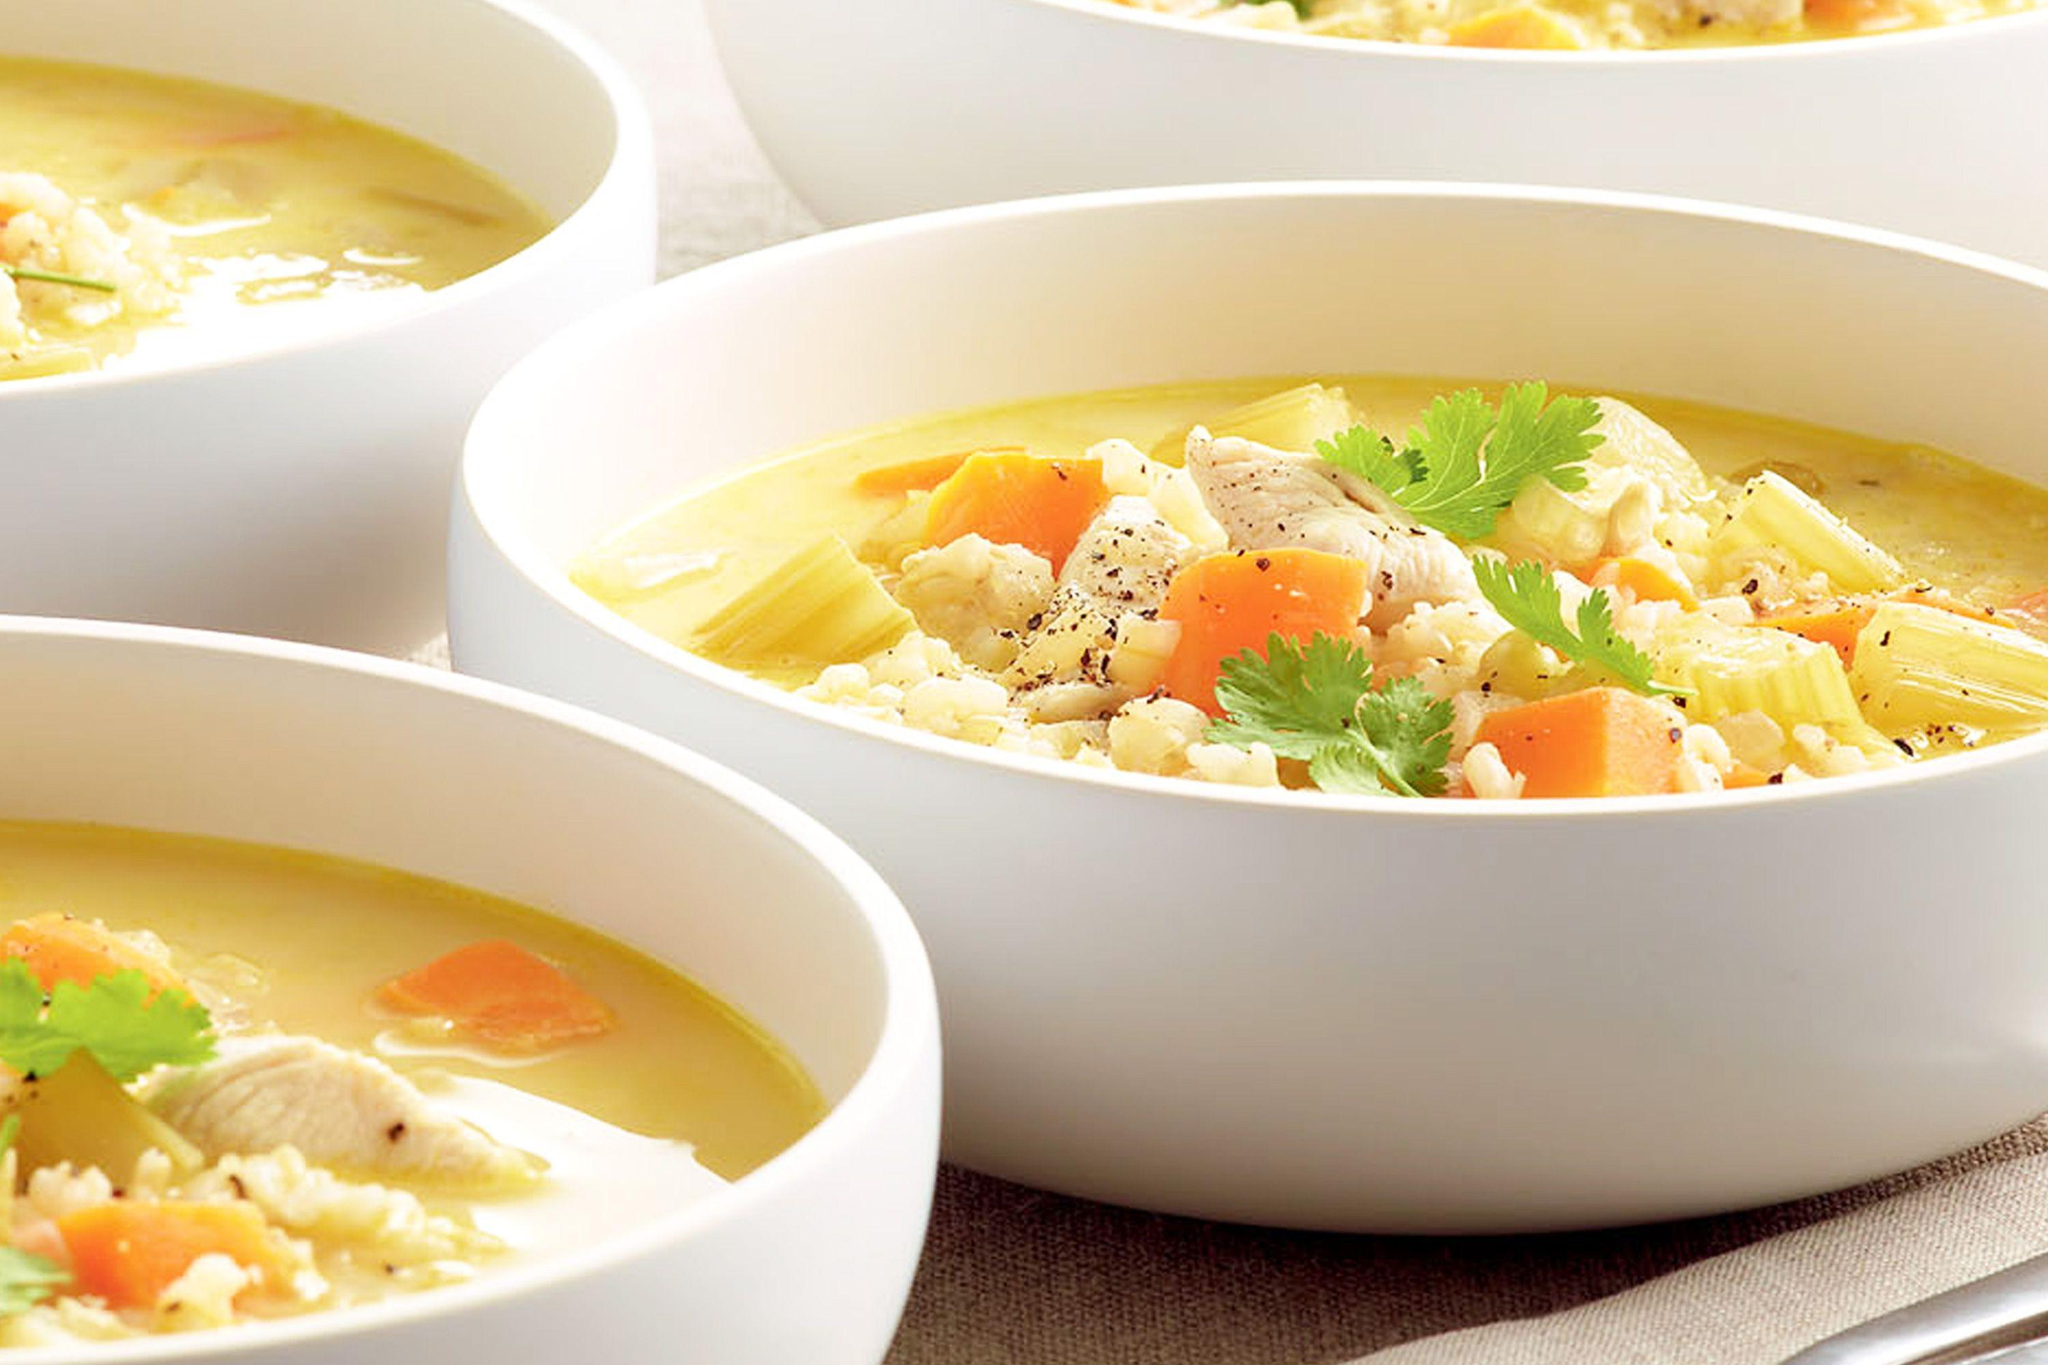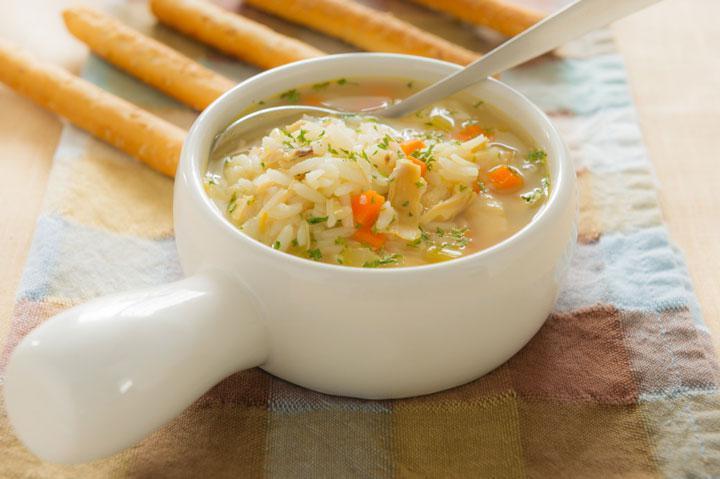The first image is the image on the left, the second image is the image on the right. Assess this claim about the two images: "A spoon is in a white bowl of chicken soup with carrots, while a second image shows two or more bowls of a different chicken soup.". Correct or not? Answer yes or no. Yes. The first image is the image on the left, the second image is the image on the right. Considering the images on both sides, is "there is a spoon in the bowl of soup" valid? Answer yes or no. Yes. 